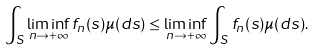<formula> <loc_0><loc_0><loc_500><loc_500>\int _ { S } \liminf _ { n \to + \infty } f _ { n } ( s ) \mu ( d s ) \leq \liminf _ { n \to + \infty } \int _ { S } f _ { n } ( s ) \mu ( d s ) .</formula> 